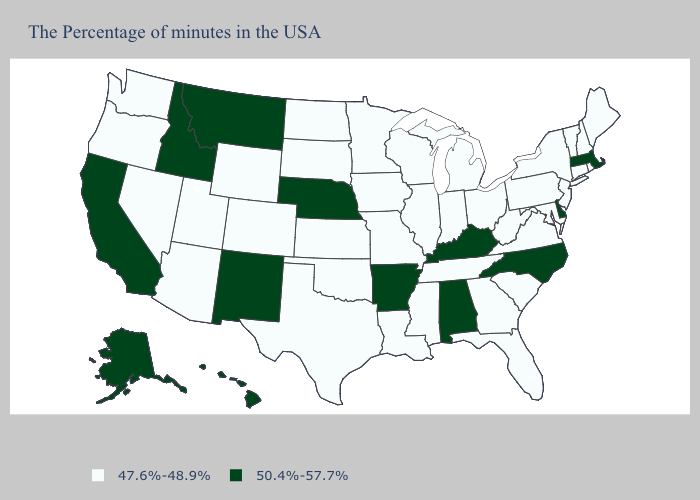Is the legend a continuous bar?
Write a very short answer. No. Name the states that have a value in the range 50.4%-57.7%?
Quick response, please. Massachusetts, Delaware, North Carolina, Kentucky, Alabama, Arkansas, Nebraska, New Mexico, Montana, Idaho, California, Alaska, Hawaii. Does New Jersey have a higher value than Mississippi?
Give a very brief answer. No. Does the map have missing data?
Short answer required. No. Which states have the highest value in the USA?
Give a very brief answer. Massachusetts, Delaware, North Carolina, Kentucky, Alabama, Arkansas, Nebraska, New Mexico, Montana, Idaho, California, Alaska, Hawaii. Does Kansas have the highest value in the MidWest?
Answer briefly. No. Name the states that have a value in the range 47.6%-48.9%?
Quick response, please. Maine, Rhode Island, New Hampshire, Vermont, Connecticut, New York, New Jersey, Maryland, Pennsylvania, Virginia, South Carolina, West Virginia, Ohio, Florida, Georgia, Michigan, Indiana, Tennessee, Wisconsin, Illinois, Mississippi, Louisiana, Missouri, Minnesota, Iowa, Kansas, Oklahoma, Texas, South Dakota, North Dakota, Wyoming, Colorado, Utah, Arizona, Nevada, Washington, Oregon. What is the lowest value in the USA?
Concise answer only. 47.6%-48.9%. What is the value of Maryland?
Short answer required. 47.6%-48.9%. Among the states that border Florida , does Alabama have the highest value?
Concise answer only. Yes. What is the lowest value in states that border Utah?
Short answer required. 47.6%-48.9%. Name the states that have a value in the range 47.6%-48.9%?
Be succinct. Maine, Rhode Island, New Hampshire, Vermont, Connecticut, New York, New Jersey, Maryland, Pennsylvania, Virginia, South Carolina, West Virginia, Ohio, Florida, Georgia, Michigan, Indiana, Tennessee, Wisconsin, Illinois, Mississippi, Louisiana, Missouri, Minnesota, Iowa, Kansas, Oklahoma, Texas, South Dakota, North Dakota, Wyoming, Colorado, Utah, Arizona, Nevada, Washington, Oregon. What is the value of Tennessee?
Give a very brief answer. 47.6%-48.9%. What is the highest value in states that border Maine?
Keep it brief. 47.6%-48.9%. Which states have the lowest value in the USA?
Answer briefly. Maine, Rhode Island, New Hampshire, Vermont, Connecticut, New York, New Jersey, Maryland, Pennsylvania, Virginia, South Carolina, West Virginia, Ohio, Florida, Georgia, Michigan, Indiana, Tennessee, Wisconsin, Illinois, Mississippi, Louisiana, Missouri, Minnesota, Iowa, Kansas, Oklahoma, Texas, South Dakota, North Dakota, Wyoming, Colorado, Utah, Arizona, Nevada, Washington, Oregon. 